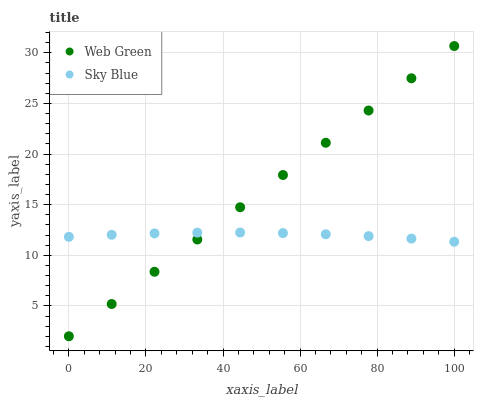Does Sky Blue have the minimum area under the curve?
Answer yes or no. Yes. Does Web Green have the maximum area under the curve?
Answer yes or no. Yes. Does Web Green have the minimum area under the curve?
Answer yes or no. No. Is Web Green the smoothest?
Answer yes or no. Yes. Is Sky Blue the roughest?
Answer yes or no. Yes. Is Web Green the roughest?
Answer yes or no. No. Does Web Green have the lowest value?
Answer yes or no. Yes. Does Web Green have the highest value?
Answer yes or no. Yes. Does Web Green intersect Sky Blue?
Answer yes or no. Yes. Is Web Green less than Sky Blue?
Answer yes or no. No. Is Web Green greater than Sky Blue?
Answer yes or no. No. 